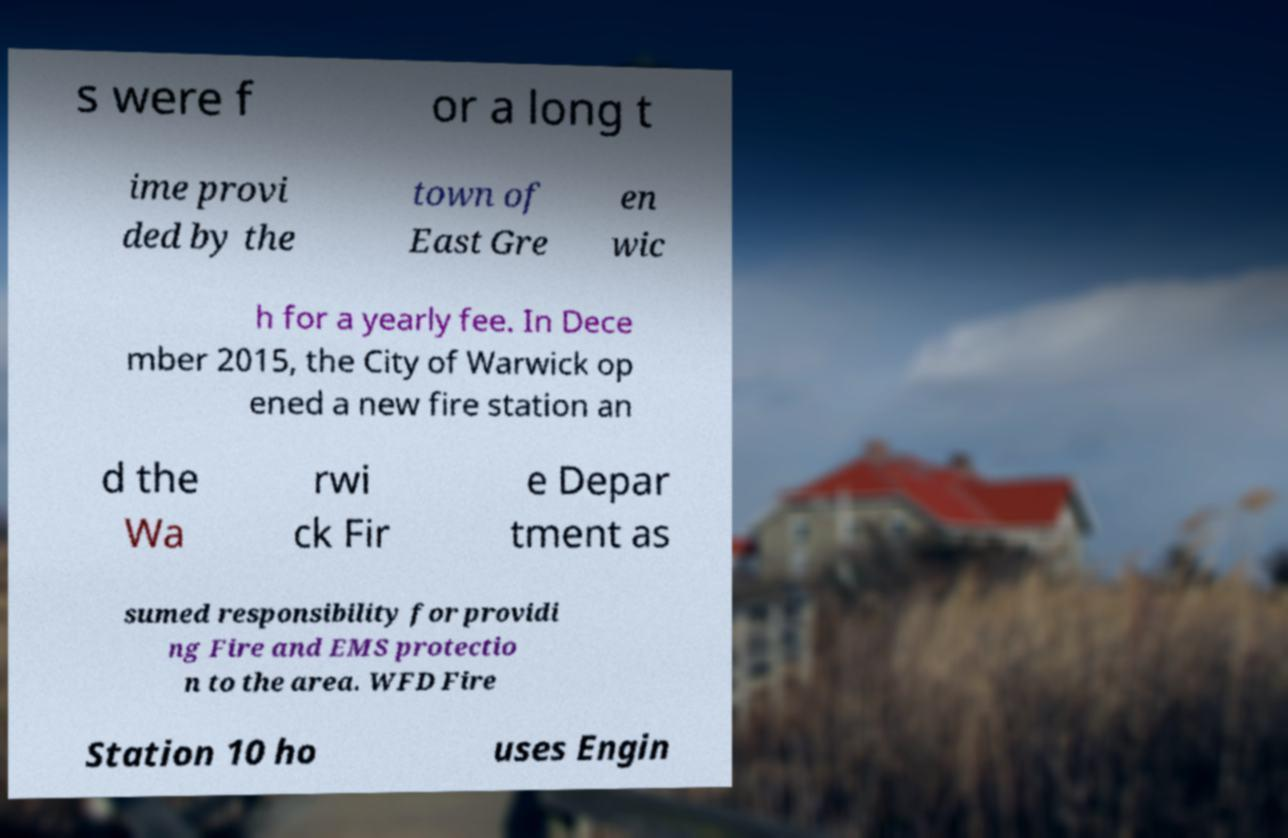Can you accurately transcribe the text from the provided image for me? s were f or a long t ime provi ded by the town of East Gre en wic h for a yearly fee. In Dece mber 2015, the City of Warwick op ened a new fire station an d the Wa rwi ck Fir e Depar tment as sumed responsibility for providi ng Fire and EMS protectio n to the area. WFD Fire Station 10 ho uses Engin 